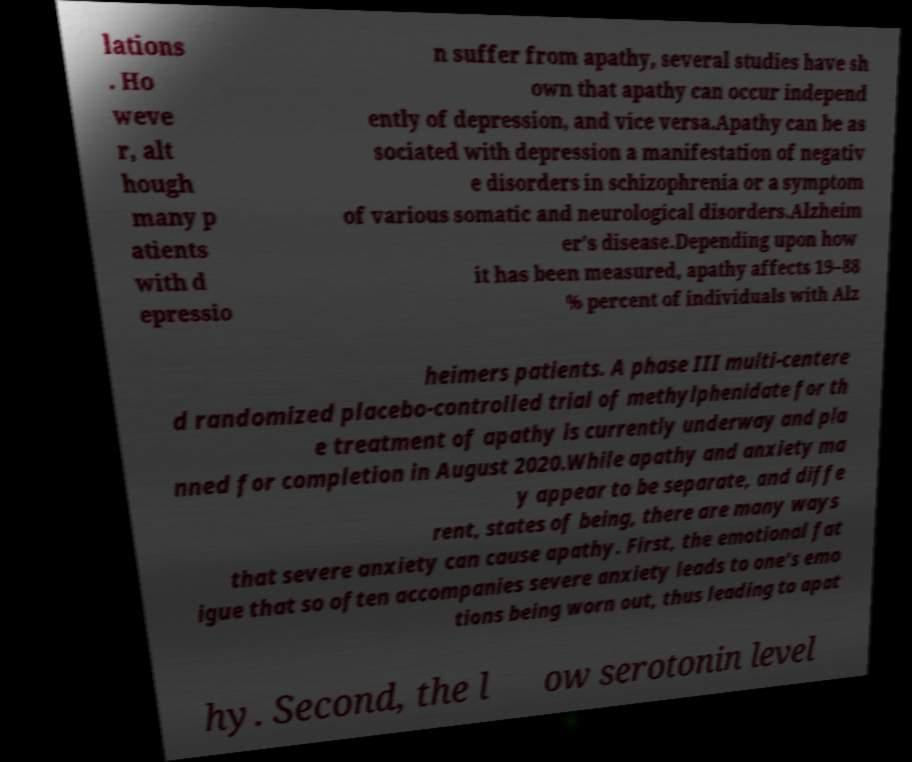I need the written content from this picture converted into text. Can you do that? lations . Ho weve r, alt hough many p atients with d epressio n suffer from apathy, several studies have sh own that apathy can occur independ ently of depression, and vice versa.Apathy can be as sociated with depression a manifestation of negativ e disorders in schizophrenia or a symptom of various somatic and neurological disorders.Alzheim er's disease.Depending upon how it has been measured, apathy affects 19–88 % percent of individuals with Alz heimers patients. A phase III multi-centere d randomized placebo-controlled trial of methylphenidate for th e treatment of apathy is currently underway and pla nned for completion in August 2020.While apathy and anxiety ma y appear to be separate, and diffe rent, states of being, there are many ways that severe anxiety can cause apathy. First, the emotional fat igue that so often accompanies severe anxiety leads to one's emo tions being worn out, thus leading to apat hy. Second, the l ow serotonin level 